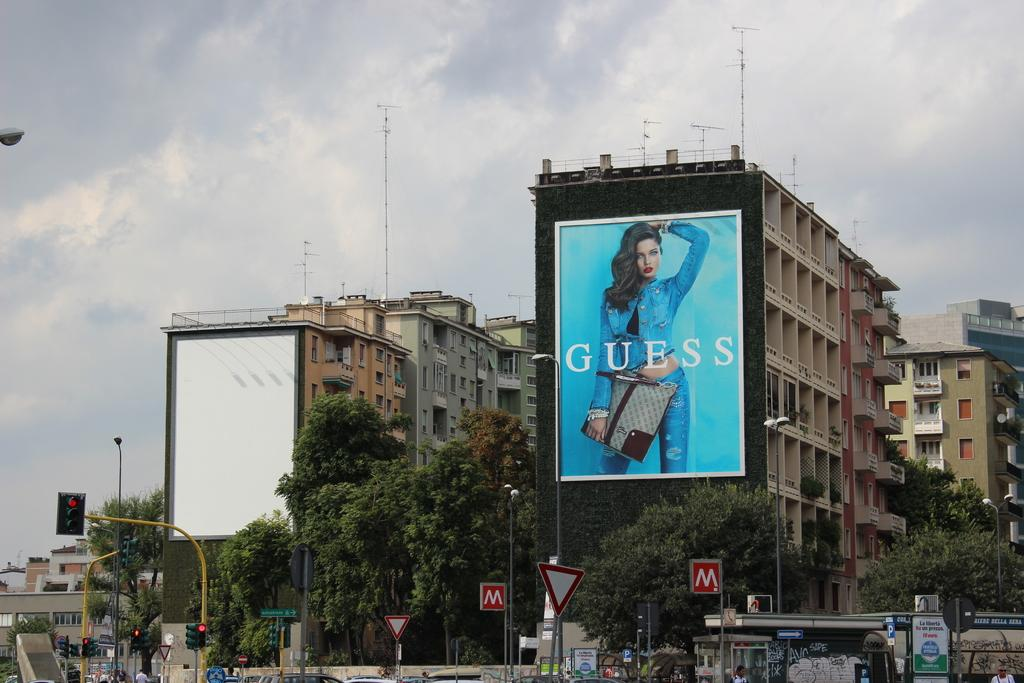<image>
Provide a brief description of the given image. The big ad on the building is for the company Guess 